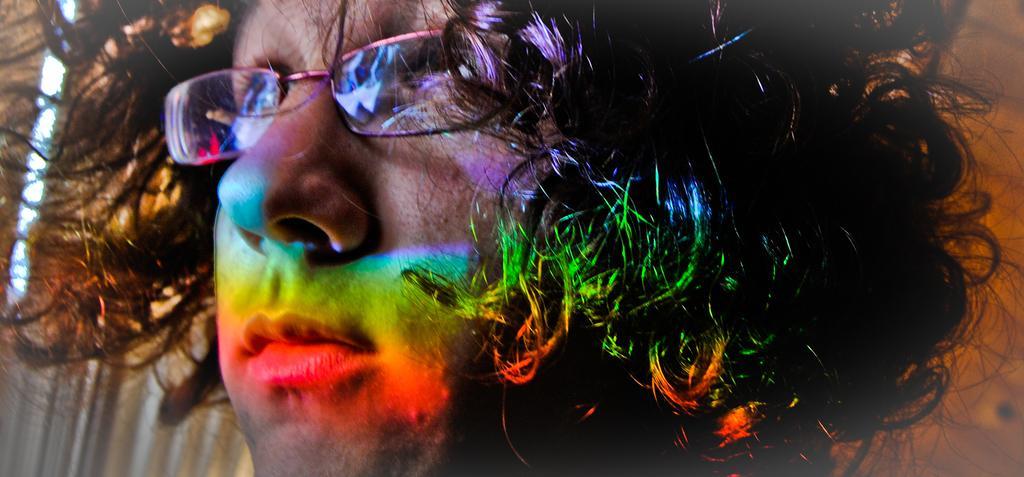Can you describe this image briefly? In this image we can see a face of a person. He is wearing glasses and we can see lights on his face. 